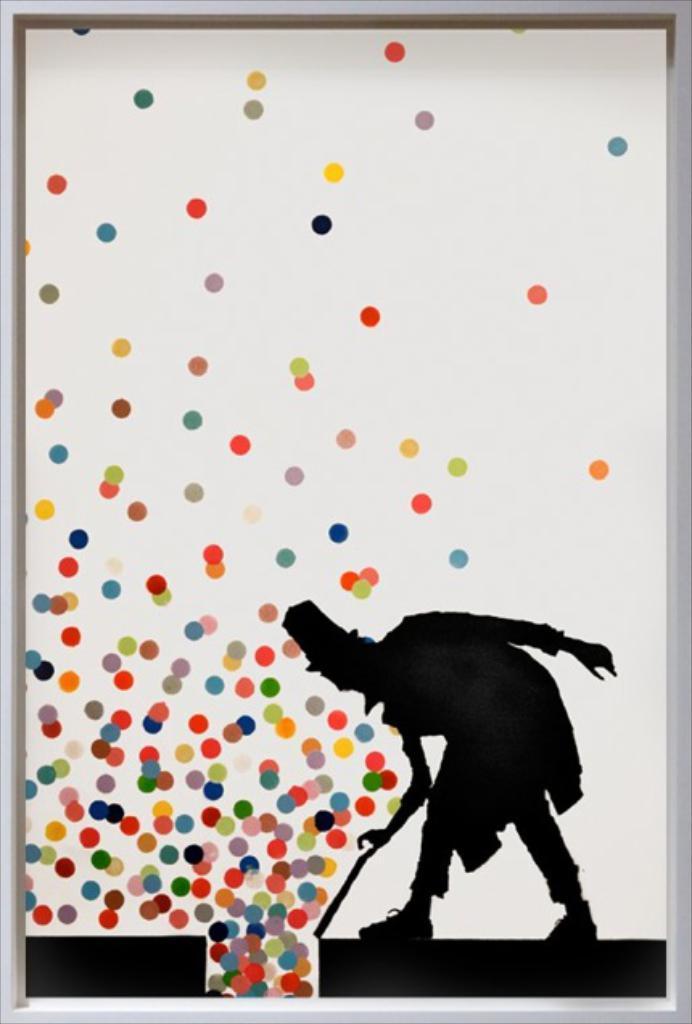Can you describe this image briefly? In this picture I can see a frame on which I can see a person who is holding a stick and I see colorful dots and I see that this is a depiction picture. 